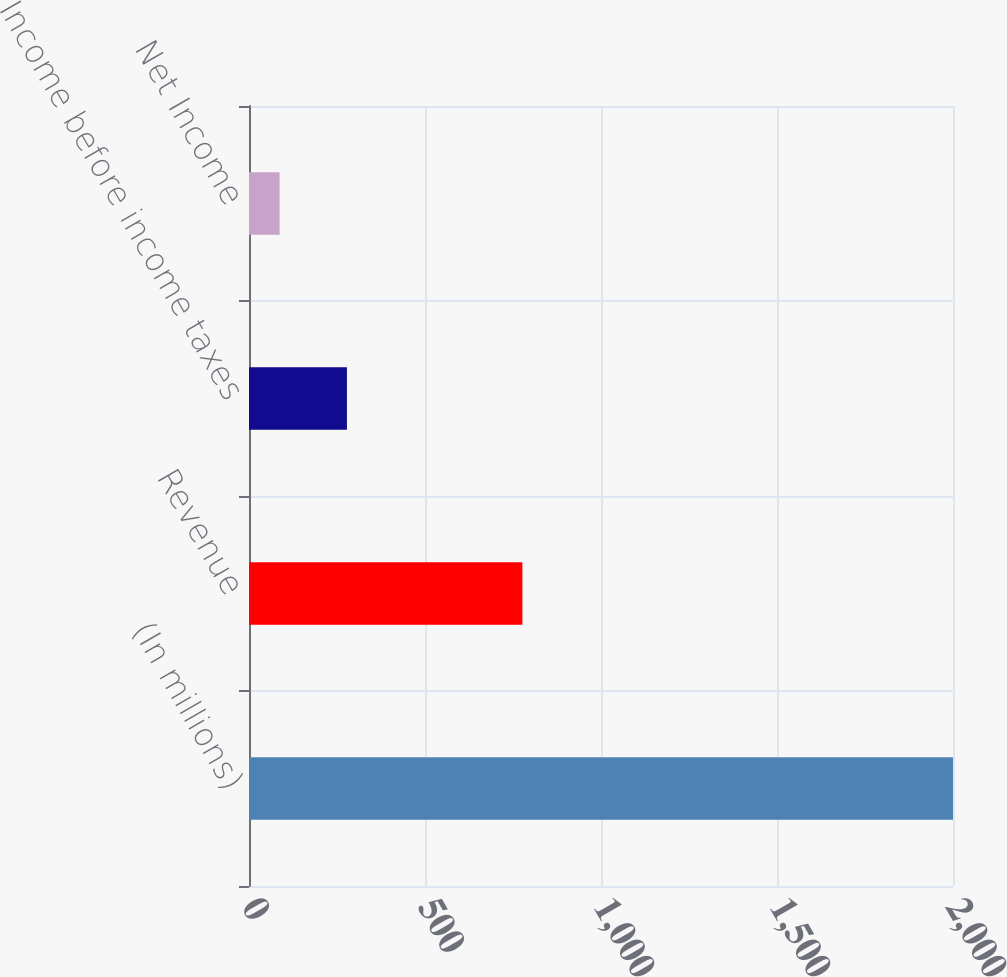Convert chart. <chart><loc_0><loc_0><loc_500><loc_500><bar_chart><fcel>(In millions)<fcel>Revenue<fcel>Income before income taxes<fcel>Net Income<nl><fcel>2000<fcel>776.7<fcel>278.21<fcel>86.9<nl></chart> 